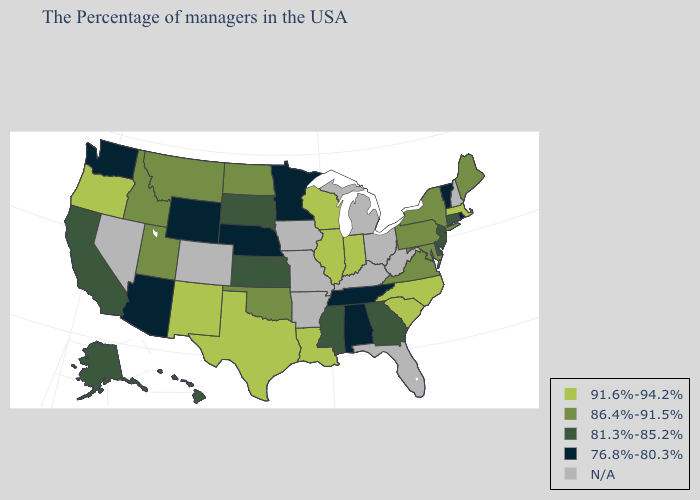What is the value of Kentucky?
Quick response, please. N/A. Name the states that have a value in the range 91.6%-94.2%?
Short answer required. Massachusetts, North Carolina, South Carolina, Indiana, Wisconsin, Illinois, Louisiana, Texas, New Mexico, Oregon. Does Oregon have the highest value in the USA?
Short answer required. Yes. What is the lowest value in states that border Iowa?
Answer briefly. 76.8%-80.3%. What is the highest value in the South ?
Be succinct. 91.6%-94.2%. Name the states that have a value in the range 86.4%-91.5%?
Be succinct. Maine, New York, Maryland, Pennsylvania, Virginia, Oklahoma, North Dakota, Utah, Montana, Idaho. Name the states that have a value in the range 86.4%-91.5%?
Concise answer only. Maine, New York, Maryland, Pennsylvania, Virginia, Oklahoma, North Dakota, Utah, Montana, Idaho. Which states have the lowest value in the MidWest?
Be succinct. Minnesota, Nebraska. What is the lowest value in the USA?
Keep it brief. 76.8%-80.3%. Does Oregon have the highest value in the West?
Quick response, please. Yes. What is the value of Minnesota?
Write a very short answer. 76.8%-80.3%. Which states have the lowest value in the USA?
Keep it brief. Rhode Island, Vermont, Alabama, Tennessee, Minnesota, Nebraska, Wyoming, Arizona, Washington. Does Wyoming have the lowest value in the USA?
Write a very short answer. Yes. 